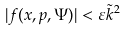<formula> <loc_0><loc_0><loc_500><loc_500>| f ( x , p , \Psi ) | < \varepsilon \tilde { k } ^ { 2 }</formula> 